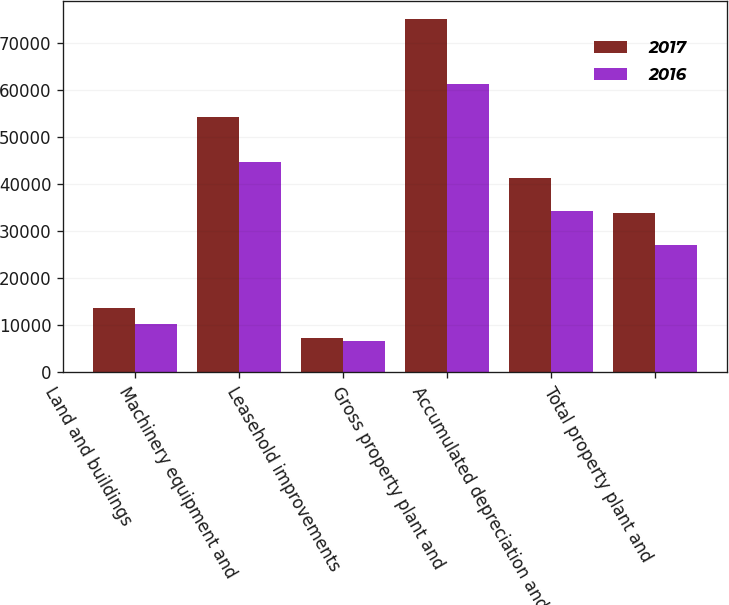Convert chart. <chart><loc_0><loc_0><loc_500><loc_500><stacked_bar_chart><ecel><fcel>Land and buildings<fcel>Machinery equipment and<fcel>Leasehold improvements<fcel>Gross property plant and<fcel>Accumulated depreciation and<fcel>Total property plant and<nl><fcel>2017<fcel>13587<fcel>54210<fcel>7279<fcel>75076<fcel>41293<fcel>33783<nl><fcel>2016<fcel>10185<fcel>44543<fcel>6517<fcel>61245<fcel>34235<fcel>27010<nl></chart> 